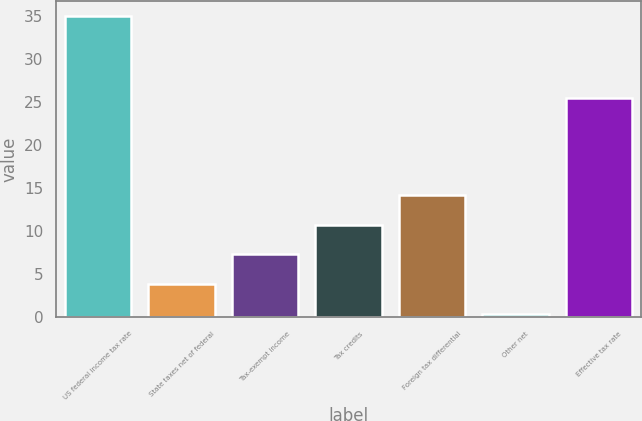Convert chart to OTSL. <chart><loc_0><loc_0><loc_500><loc_500><bar_chart><fcel>US federal income tax rate<fcel>State taxes net of federal<fcel>Tax-exempt income<fcel>Tax credits<fcel>Foreign tax differential<fcel>Other net<fcel>Effective tax rate<nl><fcel>35<fcel>3.86<fcel>7.32<fcel>10.78<fcel>14.24<fcel>0.4<fcel>25.5<nl></chart> 